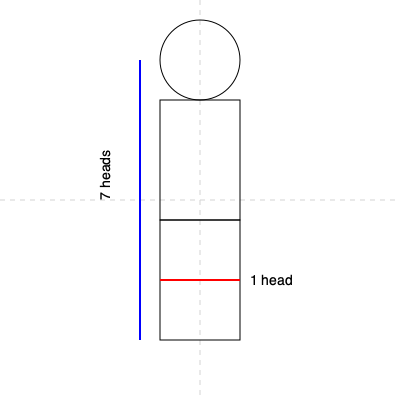In classical figure drawing, the human body is often measured in "heads." According to this anatomical guideline, how many "heads" tall is an idealized adult human figure, and where does the midpoint of the body typically fall? To answer this question, let's break down the anatomical guidelines for human figure proportions:

1. The "head" is used as a unit of measurement in figure drawing. The height of the head from the top of the skull to the bottom of the chin is considered one "head" unit.

2. In classical proportions, an idealized adult human figure is typically drawn to be 7.5 to 8 "heads" tall. For simplicity, many artists use 8 heads as a standard.

3. The body is divided into major sections using these head units:
   - Head: 1 unit
   - Torso (from chin to hip joint): 3 units
   - Legs (from hip joint to floor): 4 units

4. The midpoint of the body falls at the halfway point of the total height. In an 8-head tall figure, this would be at the 4-head mark.

5. Anatomically, the midpoint typically aligns with the pubic bone or the bottom of the hip joints.

6. In the provided diagram, we can see:
   - The figure is divided into 8 equal sections, each representing one "head" height.
   - The red line indicates one "head" unit for reference.
   - The blue line shows the full height of 7 heads, which is close to the idealized proportion.

7. The horizontal centerline in the diagram passes through the middle of the torso, which is approximately where the midpoint of the body would be located.

Therefore, according to classical anatomical guidelines, an idealized adult human figure is typically 8 heads tall, with the midpoint of the body falling at the 4-head mark, around the hip area.
Answer: 8 heads tall; midpoint at hips (4-head mark) 